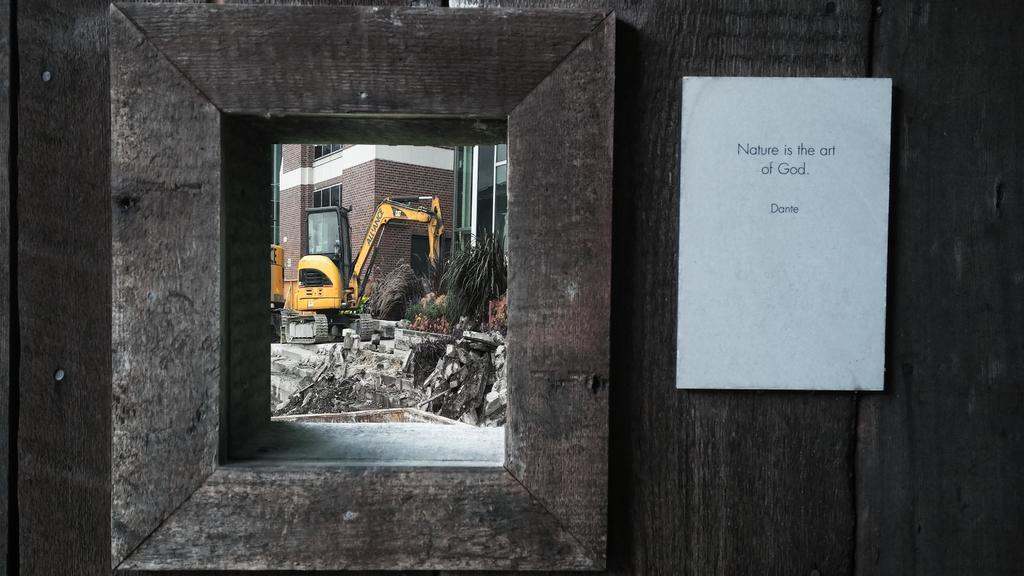In one or two sentences, can you explain what this image depicts? In this picture we can see a white board on a wooden background. There is a crane, few plants, bricks and buildings in the background. We can see a glass. 